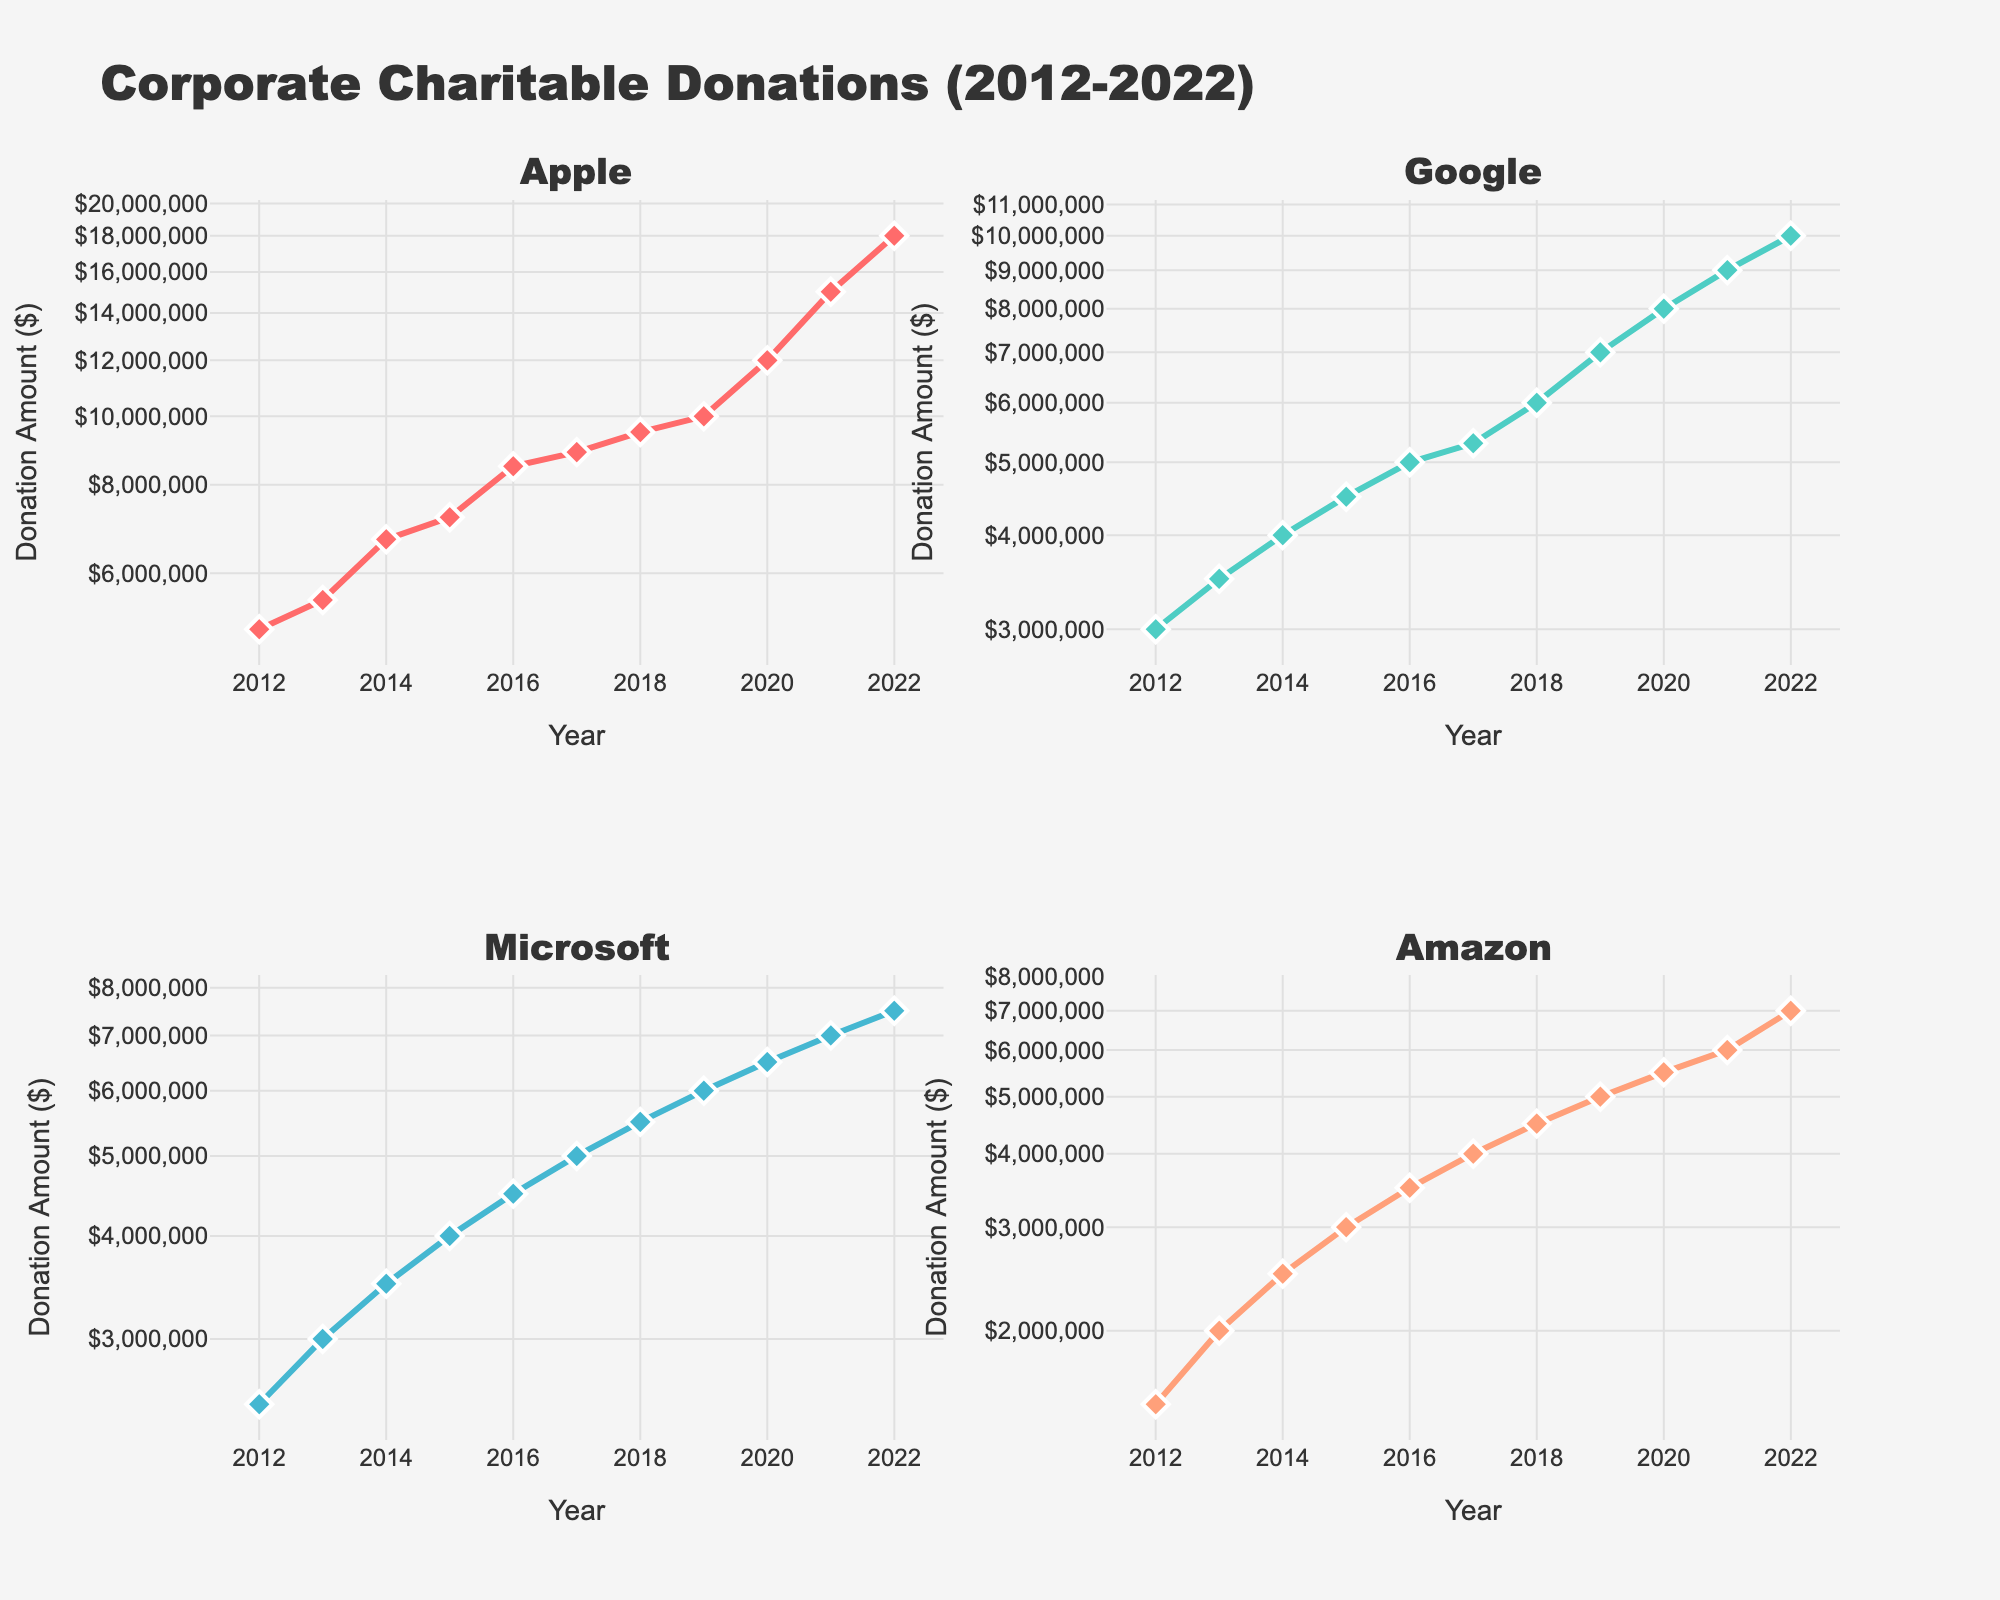What's the title of the subplots? The figure has a common title at the top. The title is visibly centered and prominent.
Answer: Corporate Charitable Donations (2012-2022) How many subplots are there in the figure? There are four distinct sections in the figure, each representing different companies.
Answer: 4 Which company had the highest donation amount in 2022? In the subplot for each company, the highest donation amount can be seen at the far-right (year 2022). Apple has the highest final marker.
Answer: Apple What is the trend in the donation amount for Amazon from 2012 to 2022? Follow the line plot in Amazon's subplot from the leftmost point (2012) to the rightmost point (2022). The line is consistently rising, indicating an upward trend.
Answer: Increasing Which company's donation remained consistently below $10,000,000? By checking the y-axis of each subplot and noting the highest donation amount for each company, Microsoft and Amazon both stayed below $10,000,000.
Answer: Microsoft and Amazon In which year did Google's donation amount hit $8,000,000? Look for the marker that points to $8,000,000 in Google's subplot and track it down to its corresponding year on the x-axis.
Answer: 2020 Comparing Apple and Google, which company saw a greater increase in donation amount between 2015 and 2022? Calculate the difference in Apple's (2022 - 2015) and Google's (2022 - 2015) donation amounts. Apple's increase: 18,000,000 - 7,200,000 = 10,800,000. Google's increase: 10,000,000 - 4,500,000 = 5,500,000. Apple had a greater increase.
Answer: Apple What is the average donation amount for Microsoft from 2012 to 2022? Sum the donation amounts for Microsoft over the years and divide by the number of years. Sum: 2,500,000 + 3,000,000 + 3,500,000 + 4,000,000 + 4,500,000 + 5,000,000 + 5,500,000 + 6,000,000 + 6,500,000 + 7,000,000 + 7,500,000 = 55,000,000. Average: 55,000,000 / 11 = 5,000,000
Answer: 5,000,000 Do all subplots have a logarithmic y-axis? Check the axis labels in each subplot. Note that the y-axis labels are logarithmic in each of the four subplots.
Answer: Yes Which company showed the least variation in donation amounts from 2012 to 2022? Compare the range (difference between maximum and minimum amounts) for each company. Amazon's donations range from 1,500,000 to 7,000,000, the smallest range compared to others.
Answer: Amazon 